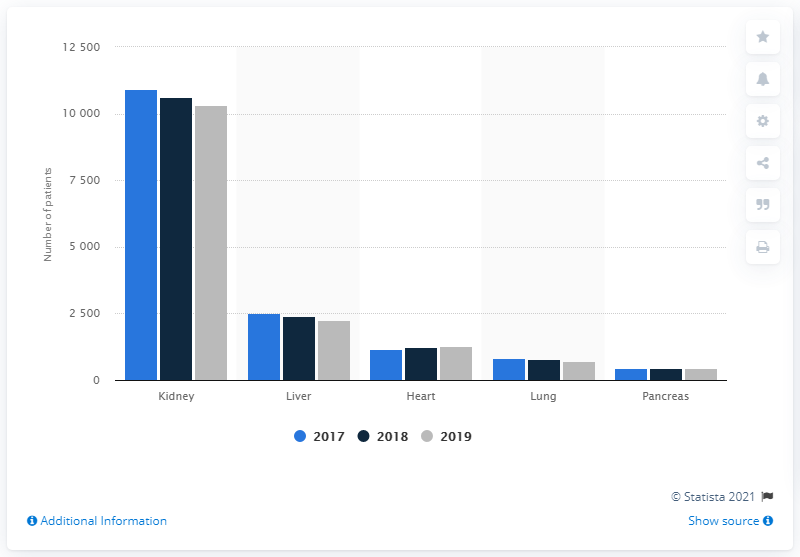List a handful of essential elements in this visual. In 2019, there were 10,325 individuals in Germany who were on a waiting list for a kidney transplant. 